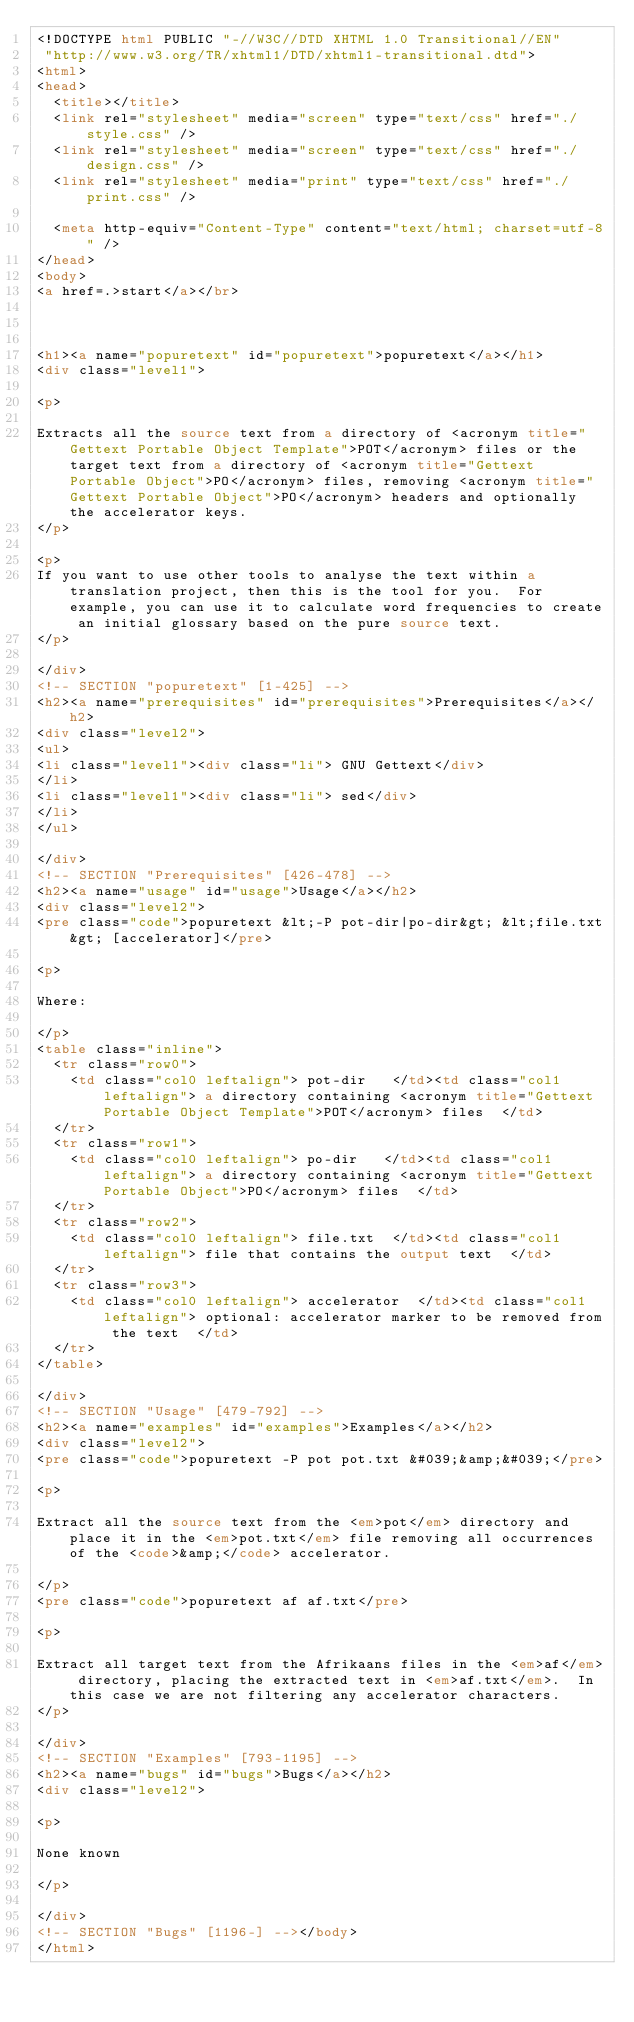Convert code to text. <code><loc_0><loc_0><loc_500><loc_500><_HTML_><!DOCTYPE html PUBLIC "-//W3C//DTD XHTML 1.0 Transitional//EN"
 "http://www.w3.org/TR/xhtml1/DTD/xhtml1-transitional.dtd">
<html>
<head>
  <title></title>
  <link rel="stylesheet" media="screen" type="text/css" href="./style.css" />
  <link rel="stylesheet" media="screen" type="text/css" href="./design.css" />
  <link rel="stylesheet" media="print" type="text/css" href="./print.css" />

  <meta http-equiv="Content-Type" content="text/html; charset=utf-8" />
</head>
<body>
<a href=.>start</a></br>



<h1><a name="popuretext" id="popuretext">popuretext</a></h1>
<div class="level1">

<p>

Extracts all the source text from a directory of <acronym title="Gettext Portable Object Template">POT</acronym> files or the target text from a directory of <acronym title="Gettext Portable Object">PO</acronym> files, removing <acronym title="Gettext Portable Object">PO</acronym> headers and optionally the accelerator keys.
</p>

<p>
If you want to use other tools to analyse the text within a translation project, then this is the tool for you.  For example, you can use it to calculate word frequencies to create an initial glossary based on the pure source text.
</p>

</div>
<!-- SECTION "popuretext" [1-425] -->
<h2><a name="prerequisites" id="prerequisites">Prerequisites</a></h2>
<div class="level2">
<ul>
<li class="level1"><div class="li"> GNU Gettext</div>
</li>
<li class="level1"><div class="li"> sed</div>
</li>
</ul>

</div>
<!-- SECTION "Prerequisites" [426-478] -->
<h2><a name="usage" id="usage">Usage</a></h2>
<div class="level2">
<pre class="code">popuretext &lt;-P pot-dir|po-dir&gt; &lt;file.txt&gt; [accelerator]</pre>

<p>

Where:

</p>
<table class="inline">
	<tr class="row0">
		<td class="col0 leftalign"> pot-dir   </td><td class="col1 leftalign"> a directory containing <acronym title="Gettext Portable Object Template">POT</acronym> files  </td>
	</tr>
	<tr class="row1">
		<td class="col0 leftalign"> po-dir   </td><td class="col1 leftalign"> a directory containing <acronym title="Gettext Portable Object">PO</acronym> files  </td>
	</tr>
	<tr class="row2">
		<td class="col0 leftalign"> file.txt  </td><td class="col1 leftalign"> file that contains the output text  </td>
	</tr>
	<tr class="row3">
		<td class="col0 leftalign"> accelerator  </td><td class="col1 leftalign"> optional: accelerator marker to be removed from the text  </td>
	</tr>
</table>

</div>
<!-- SECTION "Usage" [479-792] -->
<h2><a name="examples" id="examples">Examples</a></h2>
<div class="level2">
<pre class="code">popuretext -P pot pot.txt &#039;&amp;&#039;</pre>

<p>

Extract all the source text from the <em>pot</em> directory and place it in the <em>pot.txt</em> file removing all occurrences of the <code>&amp;</code> accelerator.

</p>
<pre class="code">popuretext af af.txt</pre>

<p>

Extract all target text from the Afrikaans files in the <em>af</em> directory, placing the extracted text in <em>af.txt</em>.  In this case we are not filtering any accelerator characters.
</p>

</div>
<!-- SECTION "Examples" [793-1195] -->
<h2><a name="bugs" id="bugs">Bugs</a></h2>
<div class="level2">

<p>

None known

</p>

</div>
<!-- SECTION "Bugs" [1196-] --></body>
</html>
</code> 